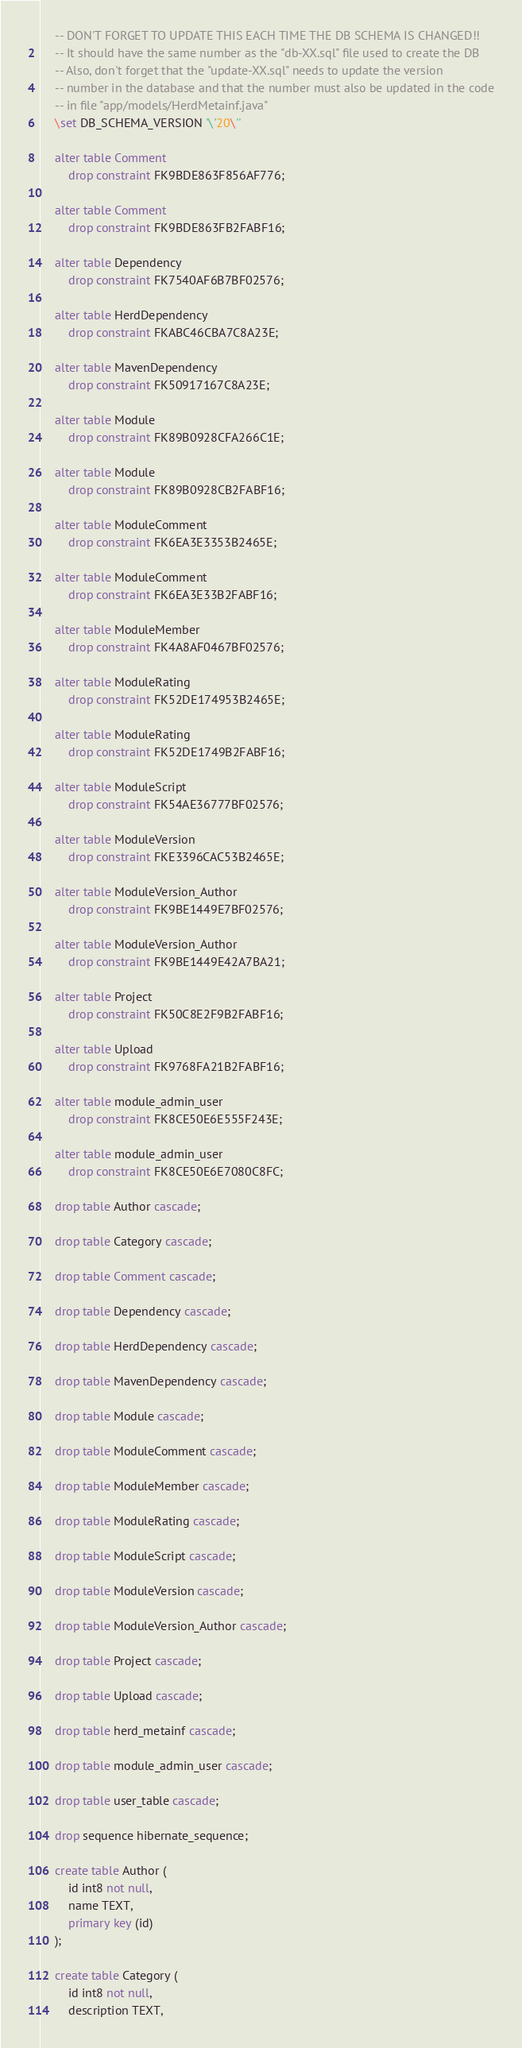Convert code to text. <code><loc_0><loc_0><loc_500><loc_500><_SQL_>    -- DON'T FORGET TO UPDATE THIS EACH TIME THE DB SCHEMA IS CHANGED!!
    -- It should have the same number as the "db-XX.sql" file used to create the DB
    -- Also, don't forget that the "update-XX.sql" needs to update the version
    -- number in the database and that the number must also be updated in the code
    -- in file "app/models/HerdMetainf.java"
    \set DB_SCHEMA_VERSION '\'20\''

    alter table Comment 
        drop constraint FK9BDE863F856AF776;

    alter table Comment 
        drop constraint FK9BDE863FB2FABF16;

    alter table Dependency 
        drop constraint FK7540AF6B7BF02576;

    alter table HerdDependency 
        drop constraint FKABC46CBA7C8A23E;

    alter table MavenDependency 
        drop constraint FK50917167C8A23E;

    alter table Module 
        drop constraint FK89B0928CFA266C1E;

    alter table Module 
        drop constraint FK89B0928CB2FABF16;

    alter table ModuleComment 
        drop constraint FK6EA3E3353B2465E;

    alter table ModuleComment 
        drop constraint FK6EA3E33B2FABF16;

    alter table ModuleMember 
        drop constraint FK4A8AF0467BF02576;

    alter table ModuleRating 
        drop constraint FK52DE174953B2465E;

    alter table ModuleRating 
        drop constraint FK52DE1749B2FABF16;

    alter table ModuleScript 
        drop constraint FK54AE36777BF02576;

    alter table ModuleVersion 
        drop constraint FKE3396CAC53B2465E;

    alter table ModuleVersion_Author 
        drop constraint FK9BE1449E7BF02576;

    alter table ModuleVersion_Author 
        drop constraint FK9BE1449E42A7BA21;

    alter table Project 
        drop constraint FK50C8E2F9B2FABF16;

    alter table Upload 
        drop constraint FK9768FA21B2FABF16;

    alter table module_admin_user 
        drop constraint FK8CE50E6E555F243E;

    alter table module_admin_user 
        drop constraint FK8CE50E6E7080C8FC;

    drop table Author cascade;

    drop table Category cascade;

    drop table Comment cascade;

    drop table Dependency cascade;

    drop table HerdDependency cascade;

    drop table MavenDependency cascade;

    drop table Module cascade;

    drop table ModuleComment cascade;

    drop table ModuleMember cascade;

    drop table ModuleRating cascade;

    drop table ModuleScript cascade;

    drop table ModuleVersion cascade;

    drop table ModuleVersion_Author cascade;

    drop table Project cascade;

    drop table Upload cascade;

    drop table herd_metainf cascade;

    drop table module_admin_user cascade;

    drop table user_table cascade;

    drop sequence hibernate_sequence;

    create table Author (
        id int8 not null,
        name TEXT,
        primary key (id)
    );

    create table Category (
        id int8 not null,
        description TEXT,</code> 